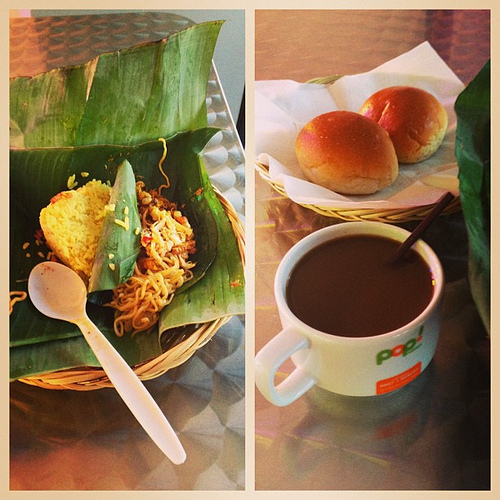What is in the basket that is on the table? The basket resting on the table cradles a pair of fluffy, golden-brown buns, an ideal complement to any meal. 